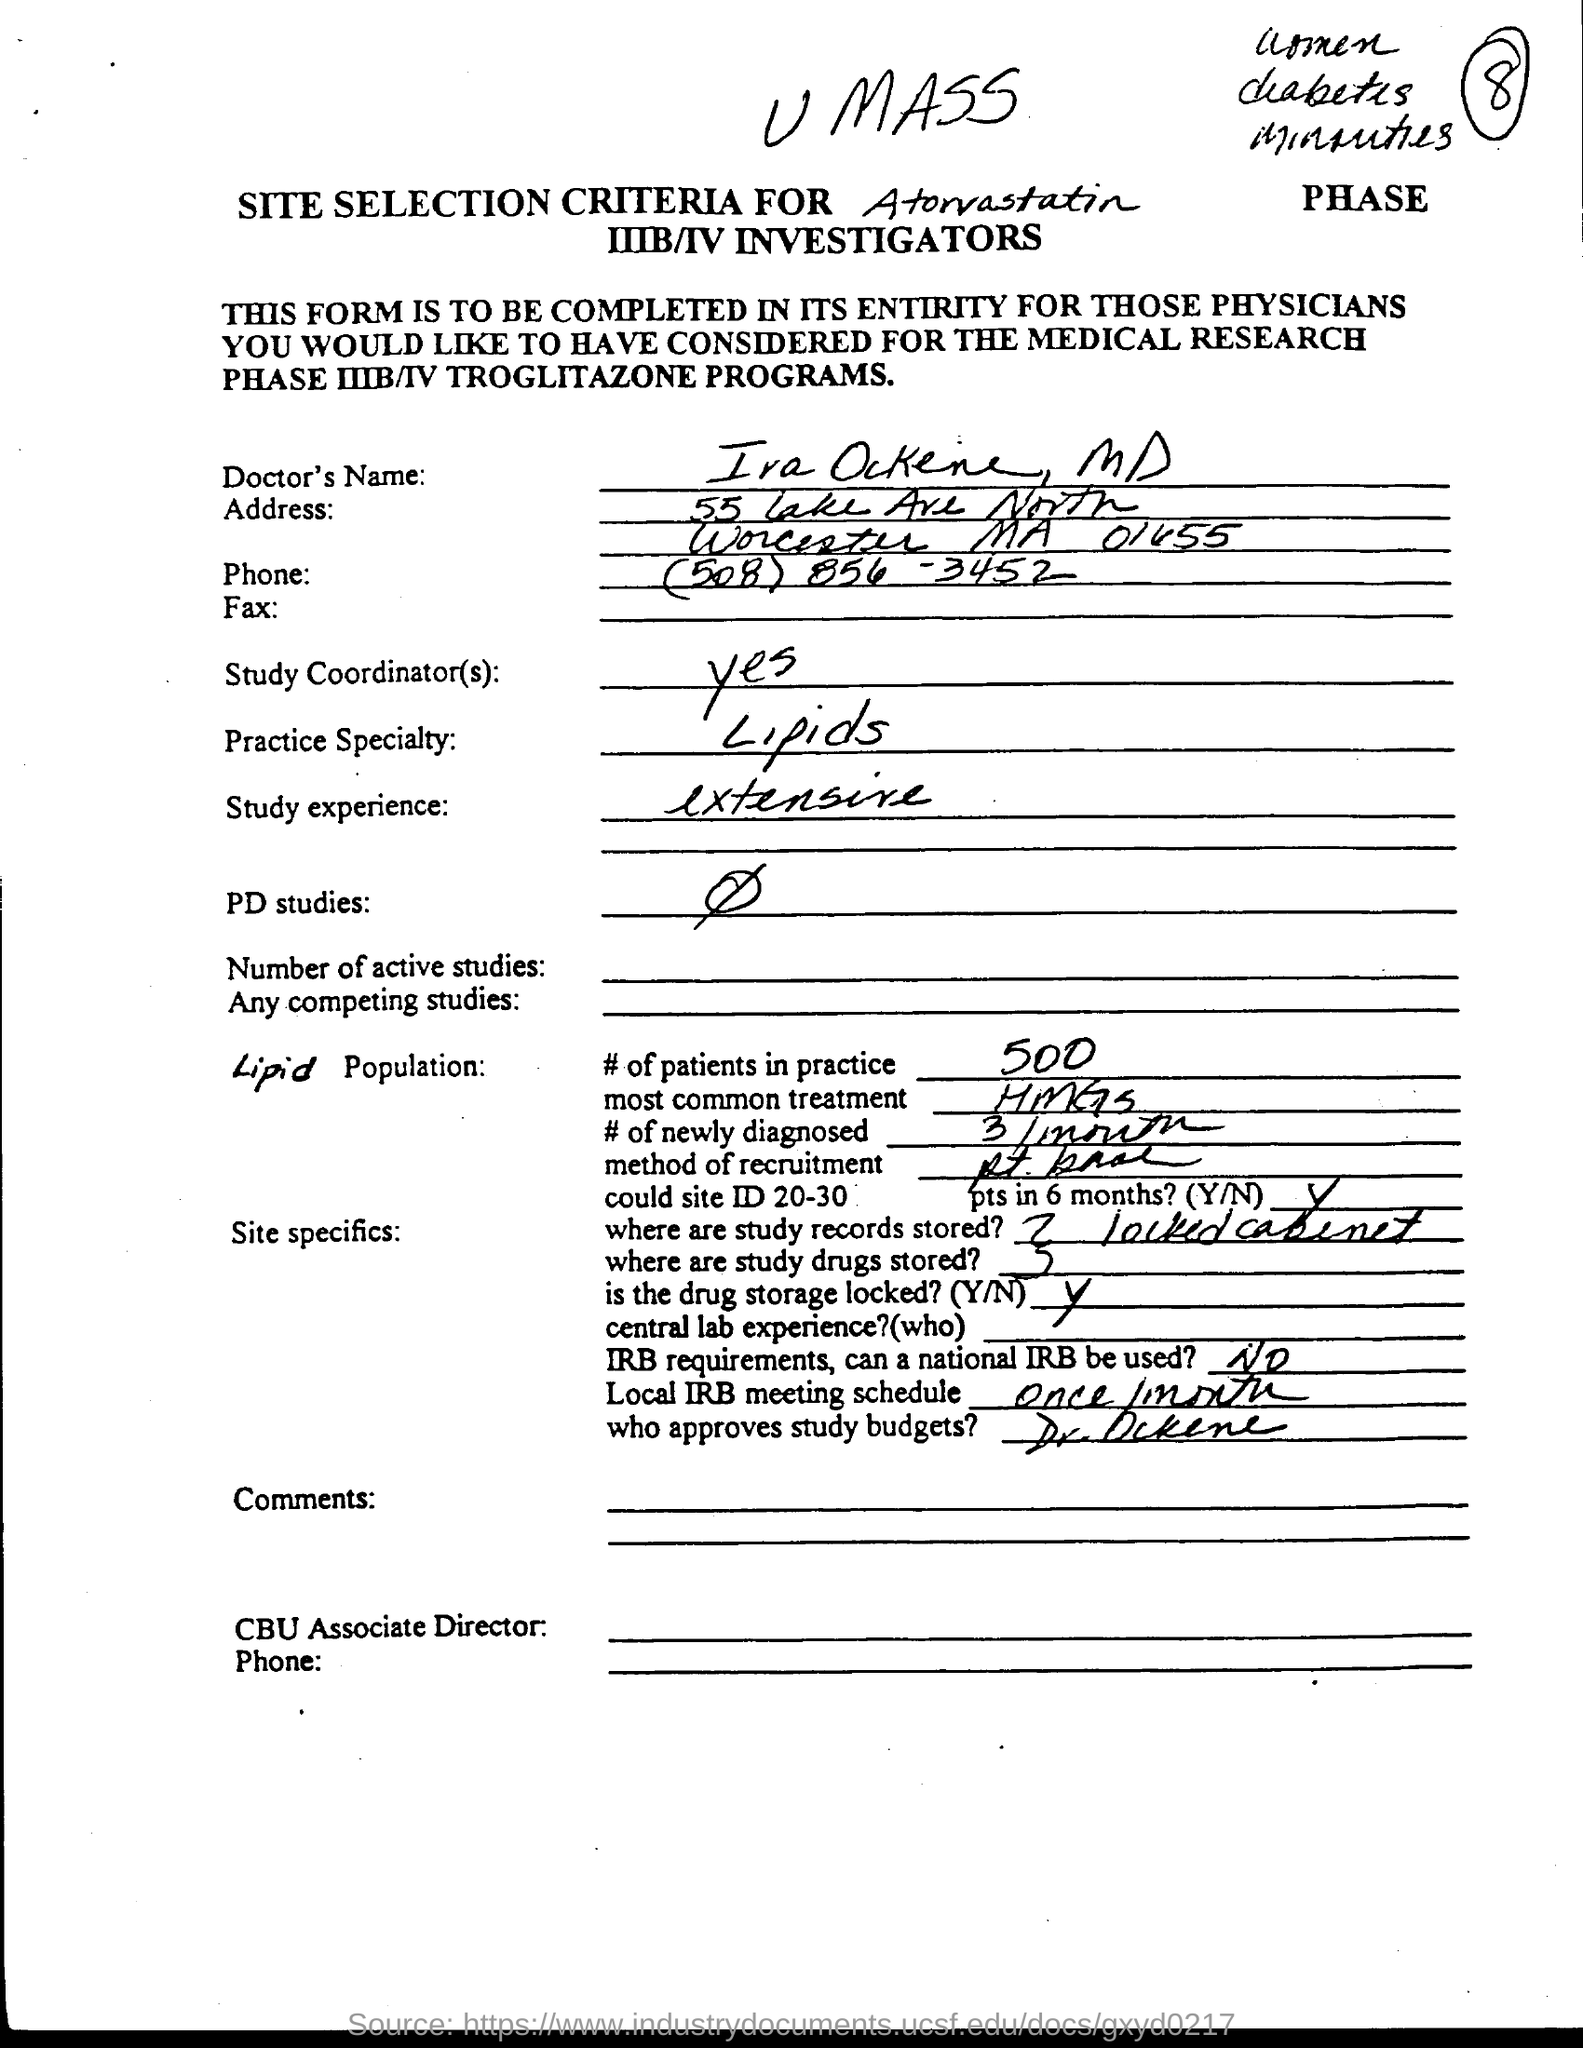Mention a couple of crucial points in this snapshot. The Doctor's practice specializes in lipid management, which involves the study and treatment of lipids, or fats, in the body. The storage of the drug is locked. (Yes or No) Is it locked? (Yes or No) Please respond with a single word. The study experience is extensive and offers a comprehensive understanding of the topic. The name of the Doctor is Ira Ockene. 